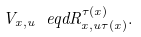<formula> <loc_0><loc_0><loc_500><loc_500>V _ { x , u } \ e q d R ^ { \tau ( x ) } _ { x , u \tau ( x ) } .</formula> 